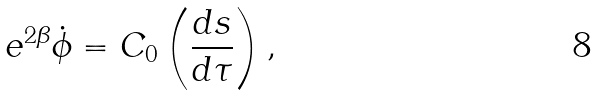<formula> <loc_0><loc_0><loc_500><loc_500>e ^ { 2 \beta } \dot { \phi } = C _ { 0 } \left ( \frac { d s } { d \tau } \right ) ,</formula> 